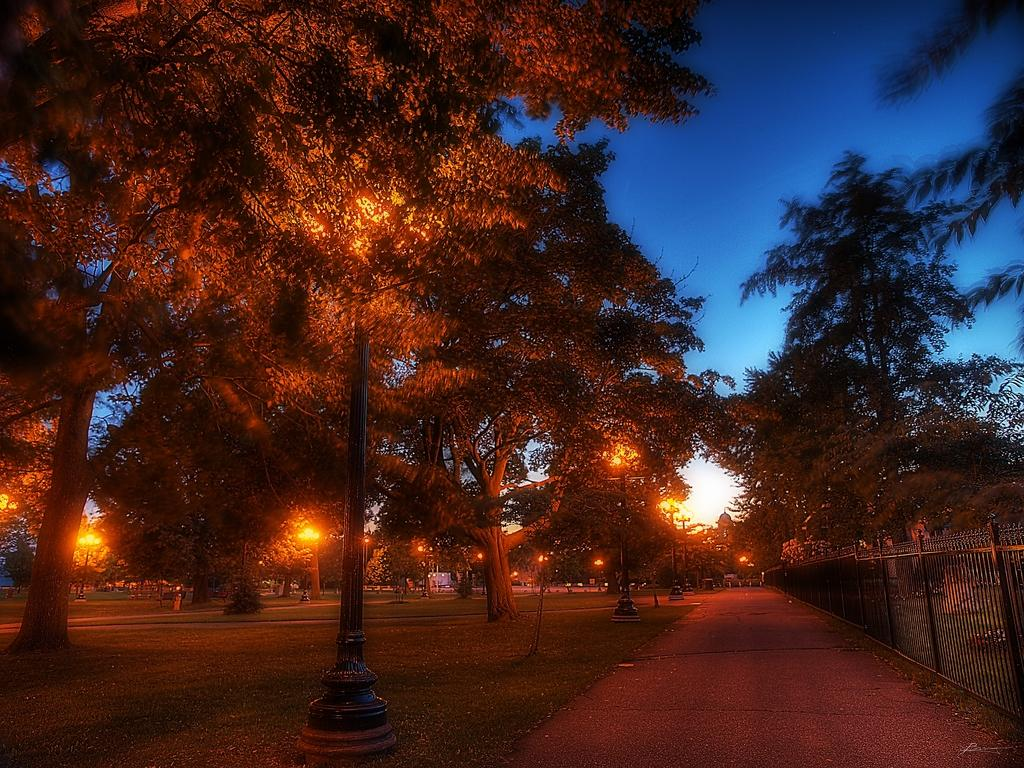What type of vegetation can be seen in the image? There are trees in the image. What structures are present in the image? There are light poles in the image. Where is the fence located in the image? The fence is on the right side of the image. What is visible in the background of the image? The sky is visible in the background of the image. What month is it in the image? The month cannot be determined from the image, as there is no information about the time of year. Can you see a beam of light in the image? There is no beam of light present in the image. 